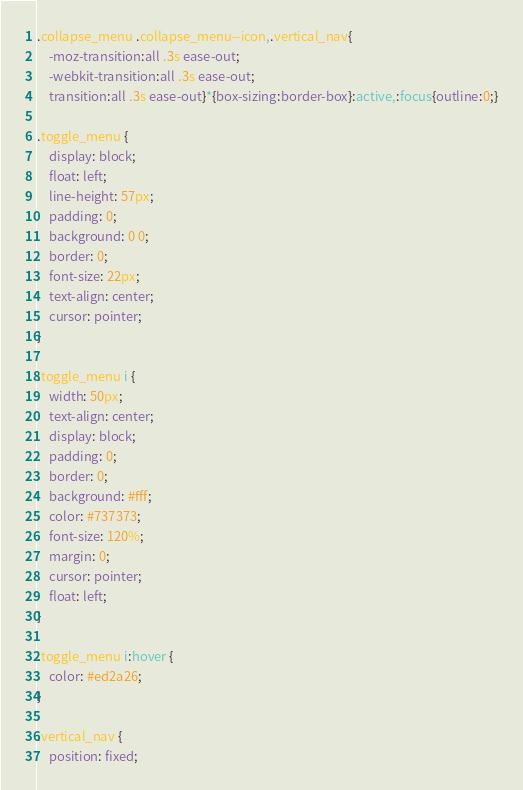<code> <loc_0><loc_0><loc_500><loc_500><_CSS_>.collapse_menu .collapse_menu--icon,.vertical_nav{
	-moz-transition:all .3s ease-out;
	-webkit-transition:all .3s ease-out;
	transition:all .3s ease-out}*{box-sizing:border-box}:active,:focus{outline:0;}

.toggle_menu {
	display: block;
	float: left;
	line-height: 57px;
	padding: 0;
	background: 0 0;
	border: 0;
	font-size: 22px;
	text-align: center;
	cursor: pointer;
}

.toggle_menu i {
	width: 50px;
    text-align: center;
    display: block;
    padding: 0;
    border: 0;
    background: #fff;
    color: #737373;
    font-size: 120%;
    margin: 0;
    cursor: pointer;
    float: left;
}

.toggle_menu i:hover {
    color: #ed2a26;
}
	
.vertical_nav {
	position: fixed;</code> 